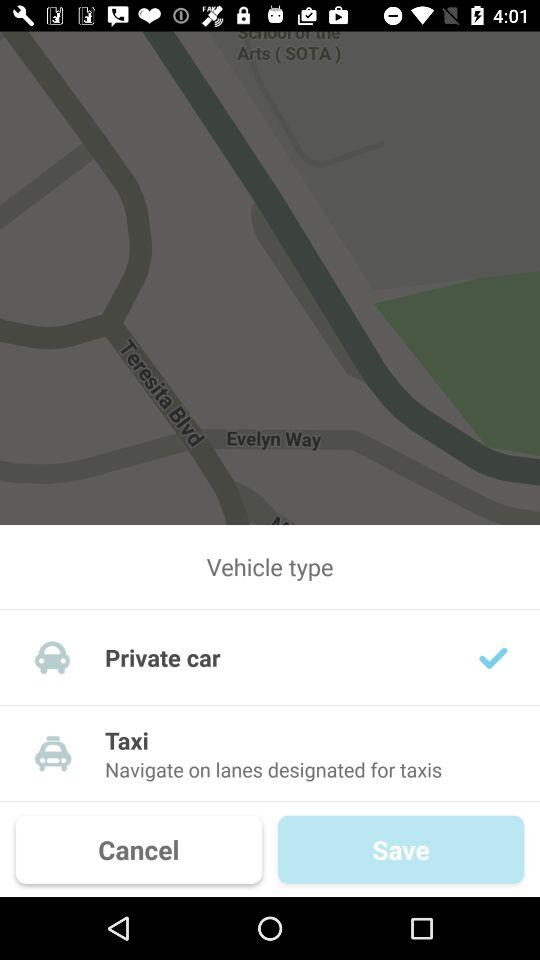How many more checkmarks are there on the taxi option than on the private car option?
Answer the question using a single word or phrase. 1 